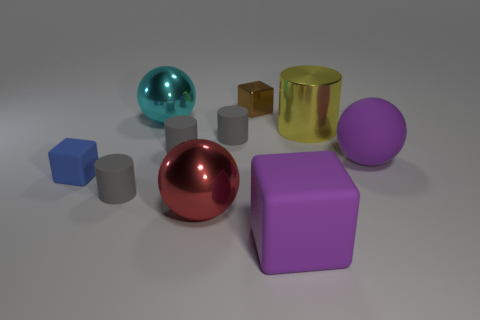Are there any tiny gray objects that have the same material as the large cylinder?
Provide a succinct answer. No. What size is the matte object that is the same color as the big rubber block?
Keep it short and to the point. Large. There is a shiny thing on the right side of the big purple cube; what color is it?
Your answer should be compact. Yellow. Is the shape of the cyan metal object the same as the purple object to the left of the yellow metal thing?
Your answer should be compact. No. Are there any balls that have the same color as the big rubber cube?
Provide a succinct answer. Yes. What is the size of the cube that is made of the same material as the blue object?
Provide a succinct answer. Large. Is the color of the large shiny cylinder the same as the matte ball?
Your answer should be very brief. No. Does the metallic thing that is to the right of the small metallic cube have the same shape as the large cyan metal thing?
Provide a short and direct response. No. What number of blocks have the same size as the brown object?
Your response must be concise. 1. There is a matte object that is the same color as the big matte cube; what is its shape?
Make the answer very short. Sphere. 